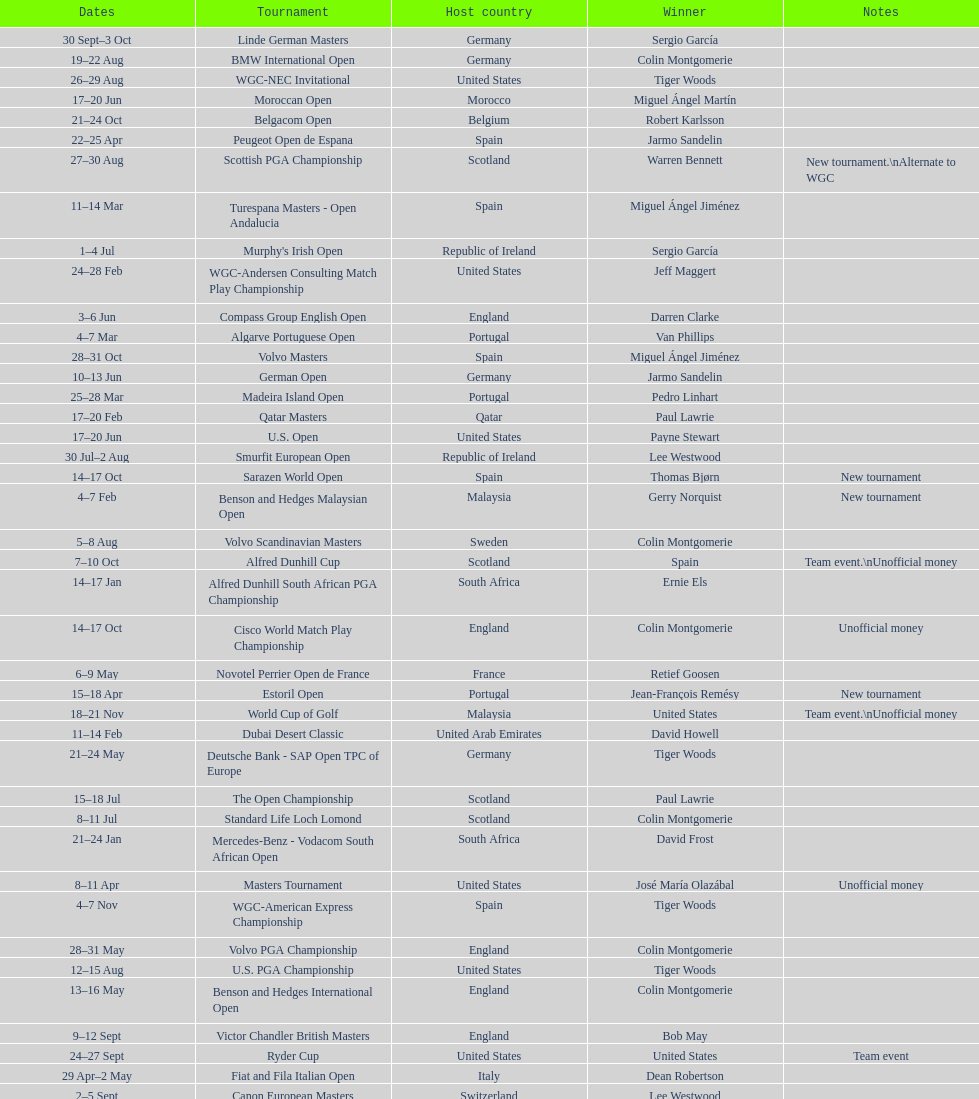How long did the estoril open last? 3 days. 